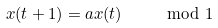Convert formula to latex. <formula><loc_0><loc_0><loc_500><loc_500>x ( t + 1 ) = a x ( t ) \quad \mod 1</formula> 